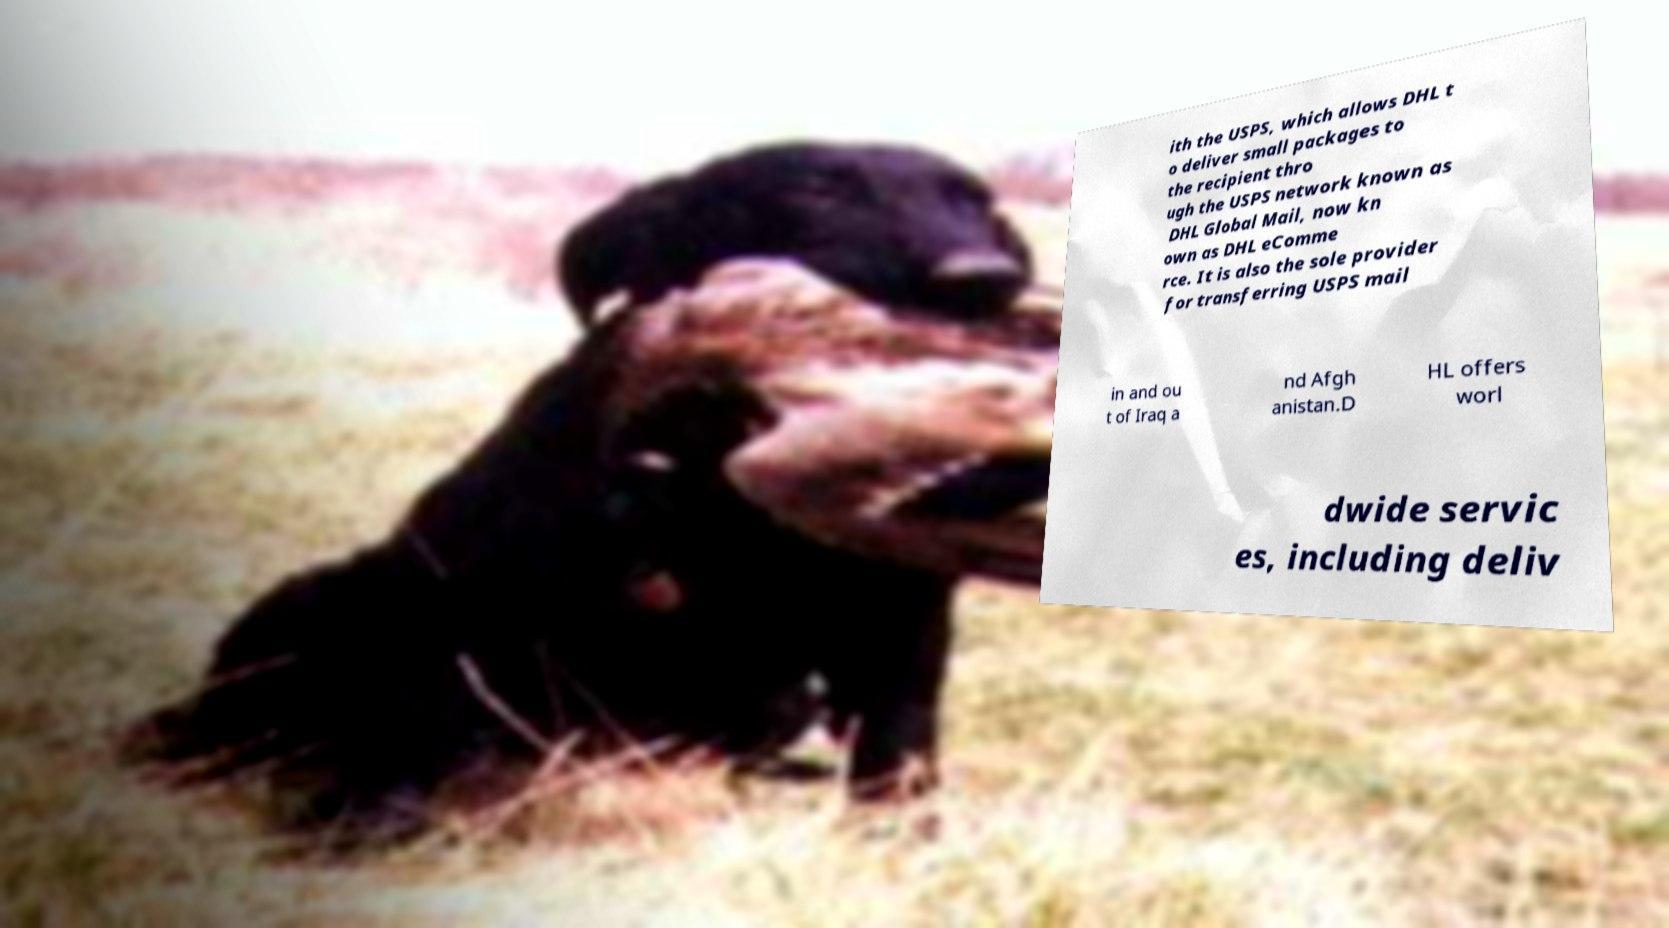There's text embedded in this image that I need extracted. Can you transcribe it verbatim? ith the USPS, which allows DHL t o deliver small packages to the recipient thro ugh the USPS network known as DHL Global Mail, now kn own as DHL eComme rce. It is also the sole provider for transferring USPS mail in and ou t of Iraq a nd Afgh anistan.D HL offers worl dwide servic es, including deliv 